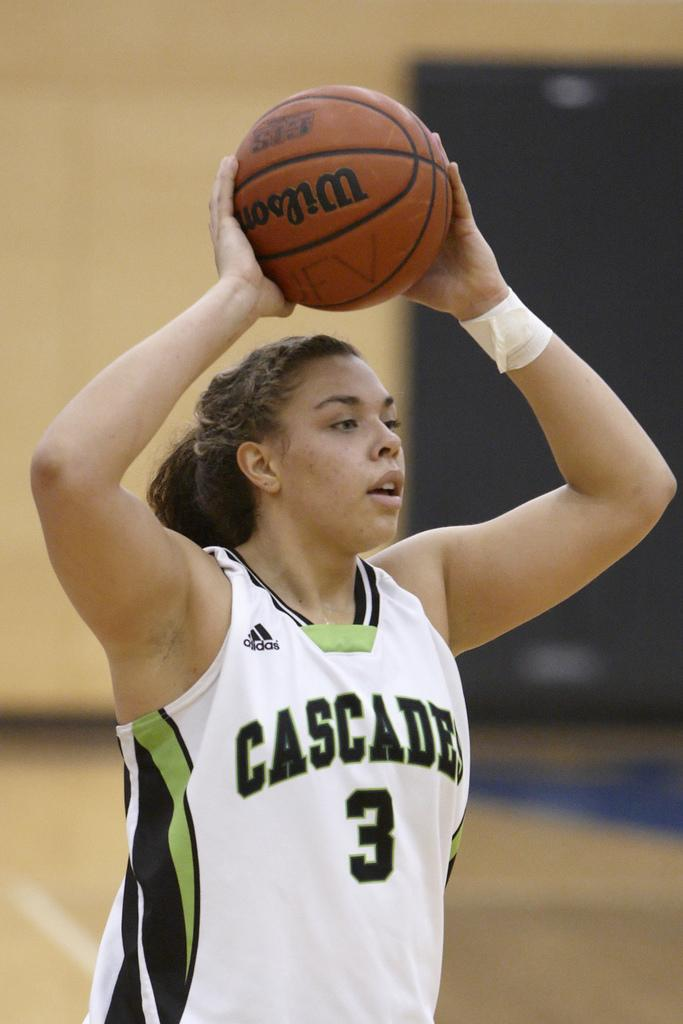<image>
Create a compact narrative representing the image presented. A girl wearing Cascade jersey number 3 is holding a basketball over her head. 